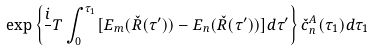Convert formula to latex. <formula><loc_0><loc_0><loc_500><loc_500>\exp \left \{ \frac { i } { } T \int _ { 0 } ^ { \tau _ { 1 } } [ E _ { m } ( \check { R } ( \tau ^ { \prime } ) ) - E _ { n } ( \check { R } ( \tau ^ { \prime } ) ) ] d \tau ^ { \prime } \right \} \check { c } _ { n } ^ { A } ( \tau _ { 1 } ) d \tau _ { 1 }</formula> 